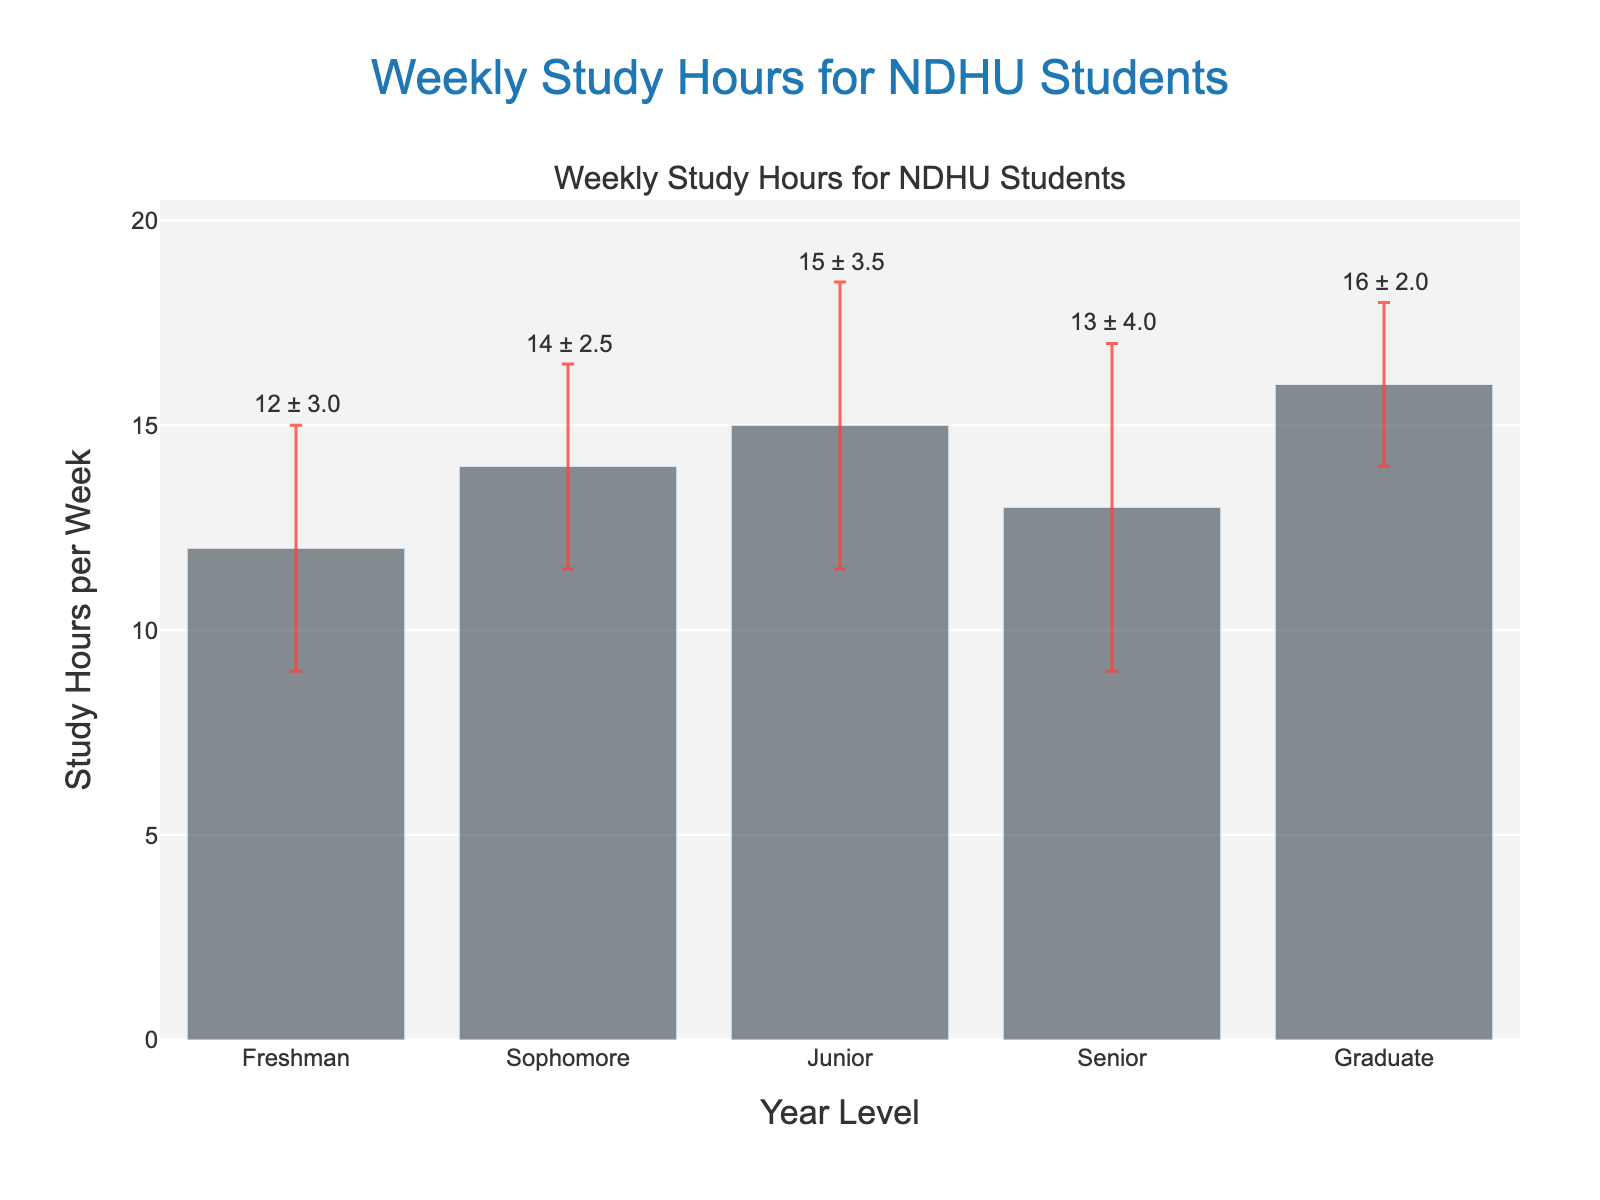What is the title of the plot? The title of the plot is usually displayed at the top of the figure. Here, it reads "Weekly Study Hours for NDHU Students."
Answer: Weekly Study Hours for NDHU Students Which year level has the highest mean study hours? By looking at the heights of the bars, the highest bar represents the Graduate level with a mean study hour of 16.
Answer: Graduate What are the mean study hours for Juniors? The bar labeled "Junior" shows the mean study hours, which is 15 hours per week.
Answer: 15 hours Which year level has the largest standard deviation in study hours? The error bars indicate the standard deviation. The Senior level has the largest error bar, representing a standard deviation of 4.
Answer: Senior What's the difference in mean study hours between Freshmen and Graduate students? The mean study hours for Freshmen is 12 and for Graduate students is 16. The difference is calculated as 16 - 12.
Answer: 4 hours What is the range of study hours displayed on the y-axis? The y-axis begins at 0 and extends to a value slightly above the maximum mean study hours plus the standard deviation. Here, it ranges from 0 to approximately 18.
Answer: 0 - 18 Do Sophomores have more or less study hours on average than Seniors? By comparing the heights of the bars, Sophomores (14 hours) study more on average than Seniors (13 hours).
Answer: More What does the value "12 ± 3" represent on the Freshman bar? The value "12 ± 3" indicates that Freshmen students have a mean of 12 study hours per week, with a standard deviation of 3 hours.
Answer: Freshman mean and standard deviation Which year level has the smallest variation in study hours? The smallest standard deviation (shortest error bar) is seen for Graduate students, indicating the least variation at 2 hours.
Answer: Graduate 